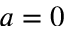Convert formula to latex. <formula><loc_0><loc_0><loc_500><loc_500>a = 0</formula> 